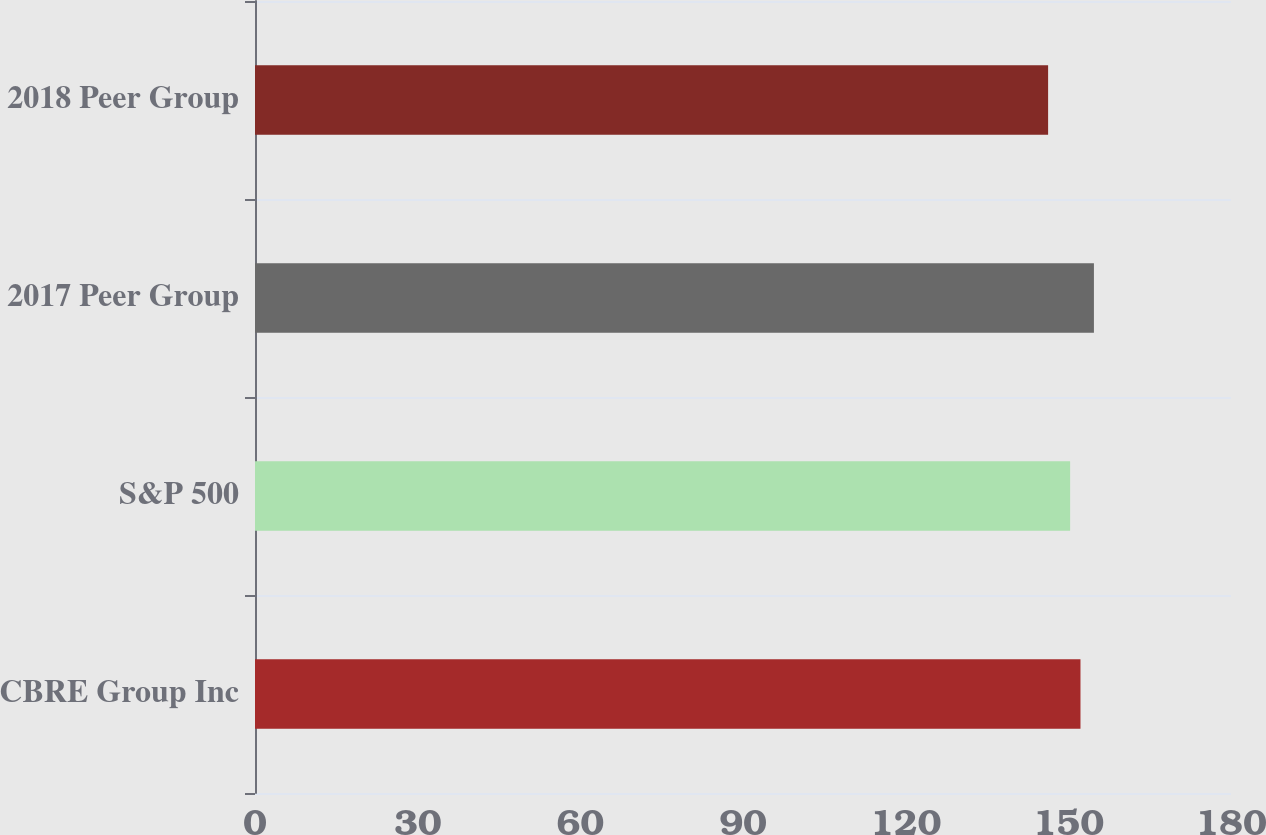Convert chart. <chart><loc_0><loc_0><loc_500><loc_500><bar_chart><fcel>CBRE Group Inc<fcel>S&P 500<fcel>2017 Peer Group<fcel>2018 Peer Group<nl><fcel>152.24<fcel>150.33<fcel>154.72<fcel>146.27<nl></chart> 